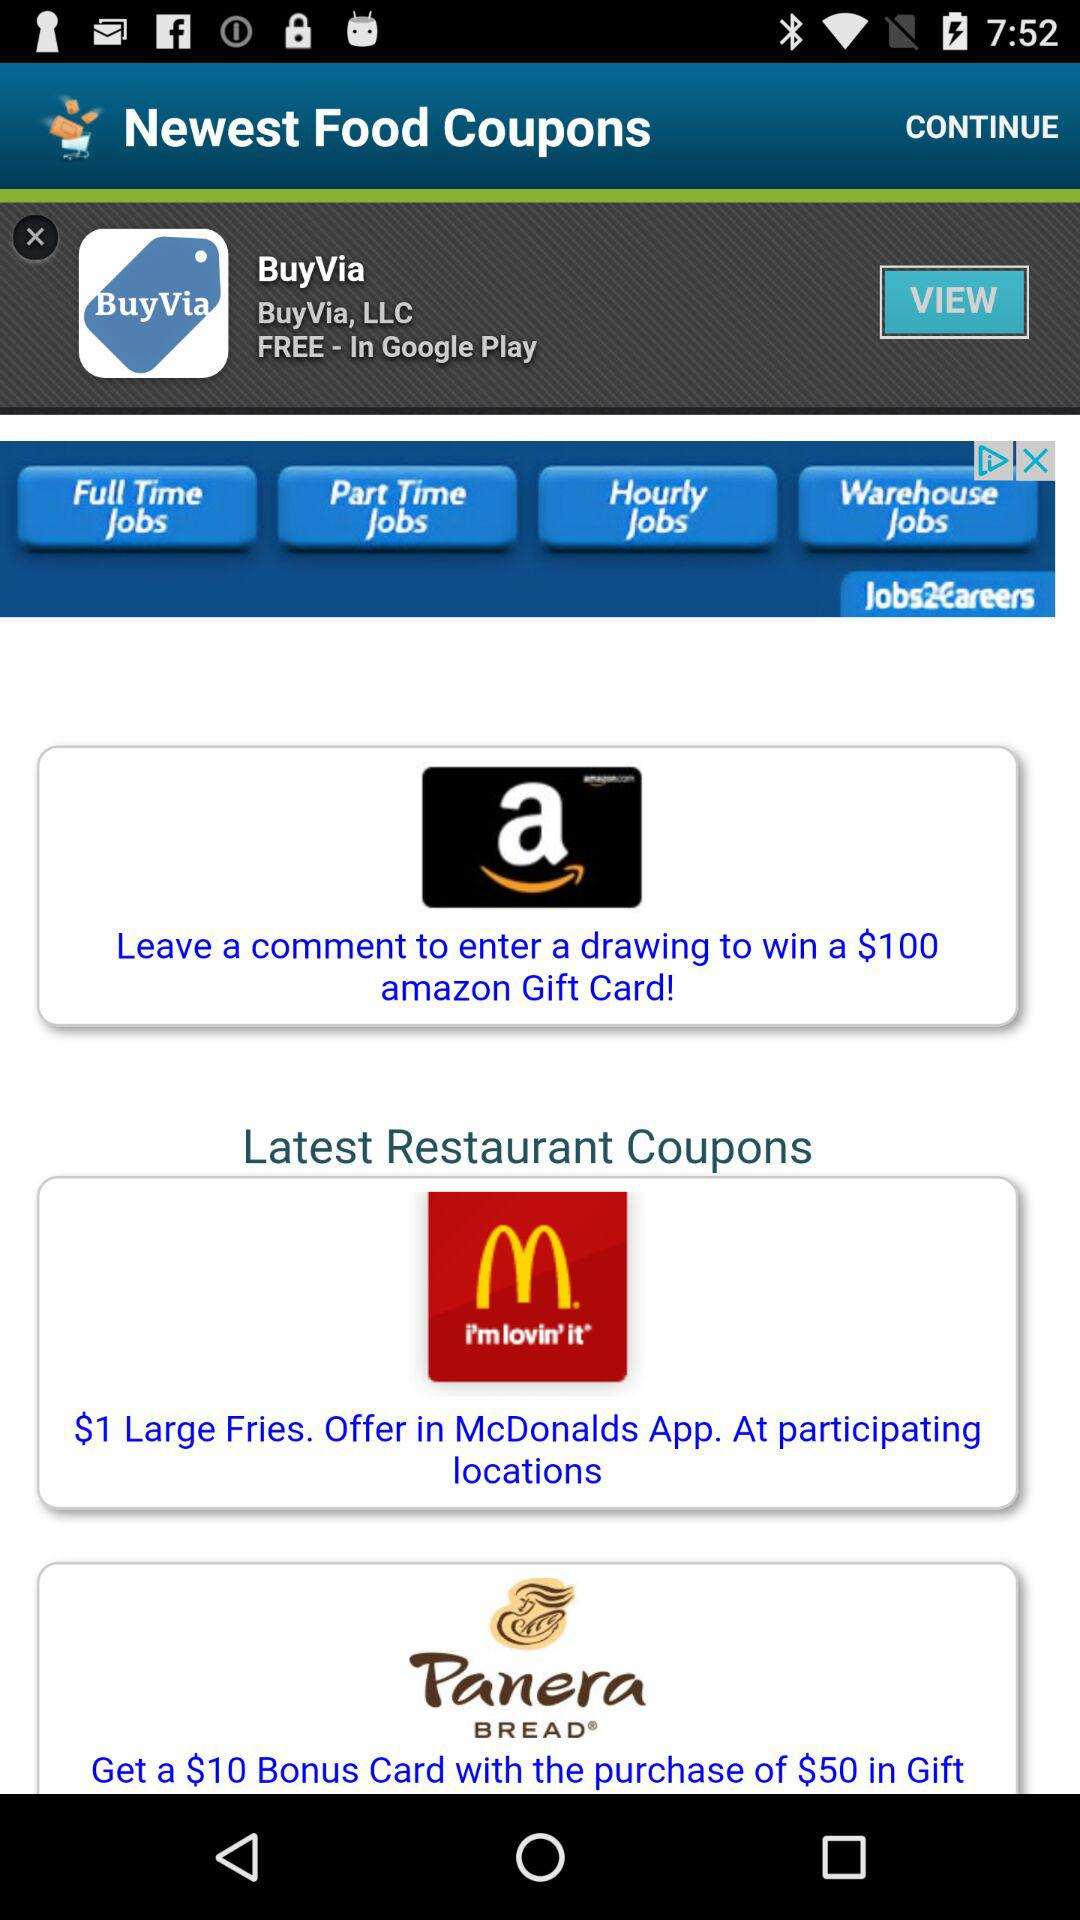What is the amount of the Amazon gift card? The amount of the Amazon gift card is $100. 